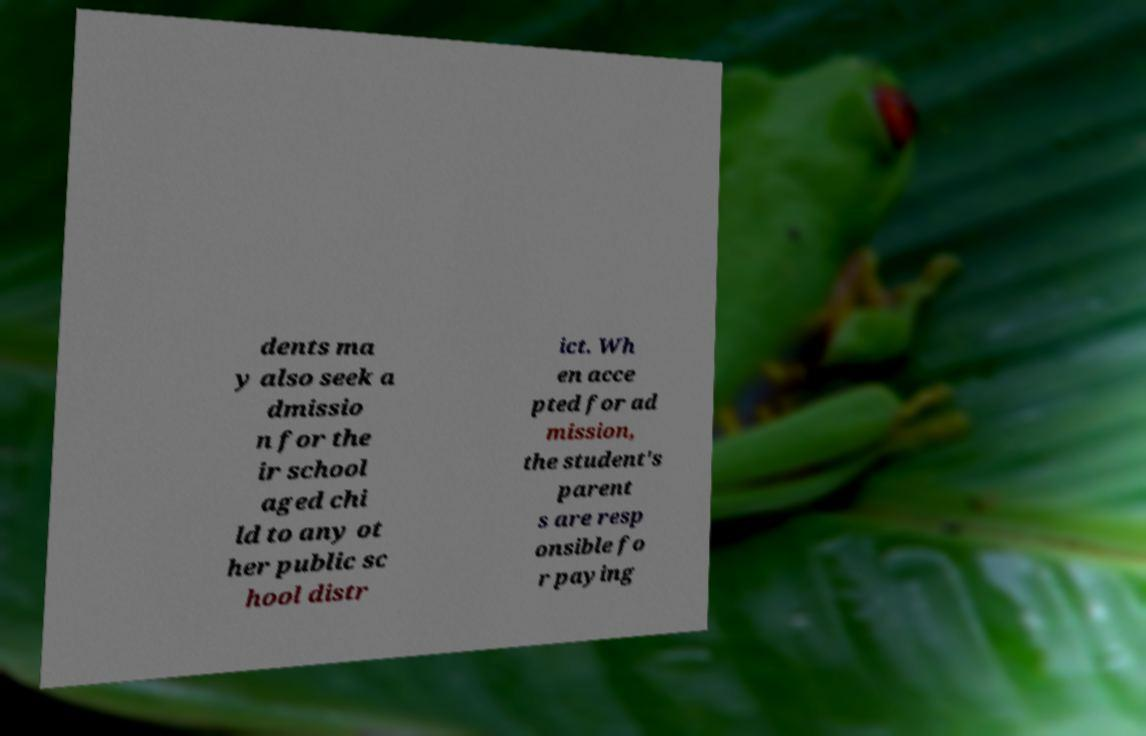What messages or text are displayed in this image? I need them in a readable, typed format. dents ma y also seek a dmissio n for the ir school aged chi ld to any ot her public sc hool distr ict. Wh en acce pted for ad mission, the student's parent s are resp onsible fo r paying 